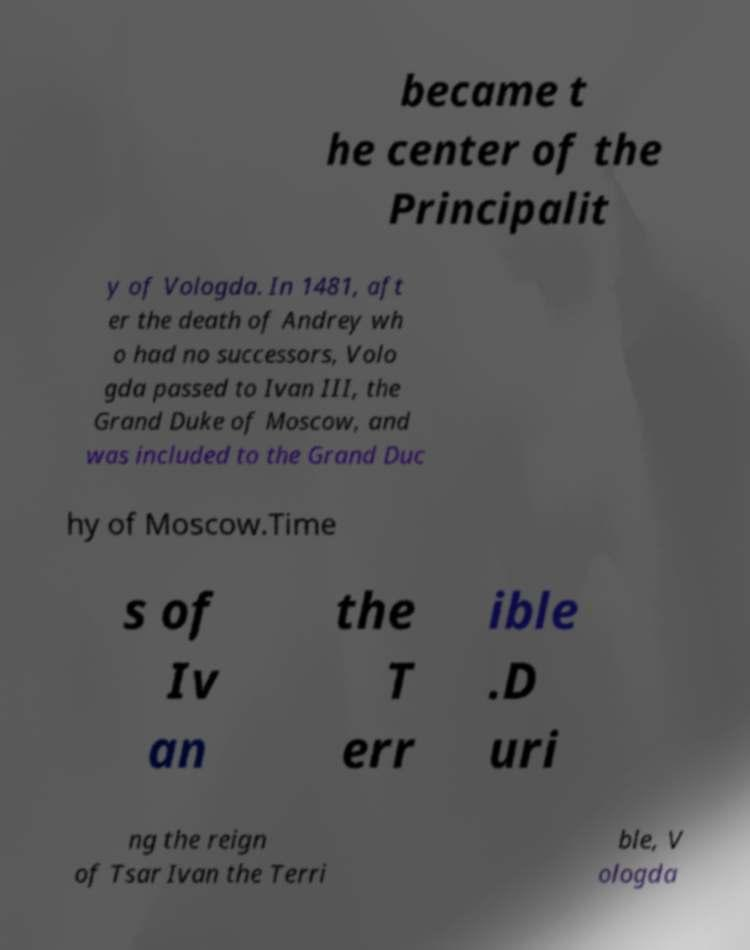Can you accurately transcribe the text from the provided image for me? became t he center of the Principalit y of Vologda. In 1481, aft er the death of Andrey wh o had no successors, Volo gda passed to Ivan III, the Grand Duke of Moscow, and was included to the Grand Duc hy of Moscow.Time s of Iv an the T err ible .D uri ng the reign of Tsar Ivan the Terri ble, V ologda 